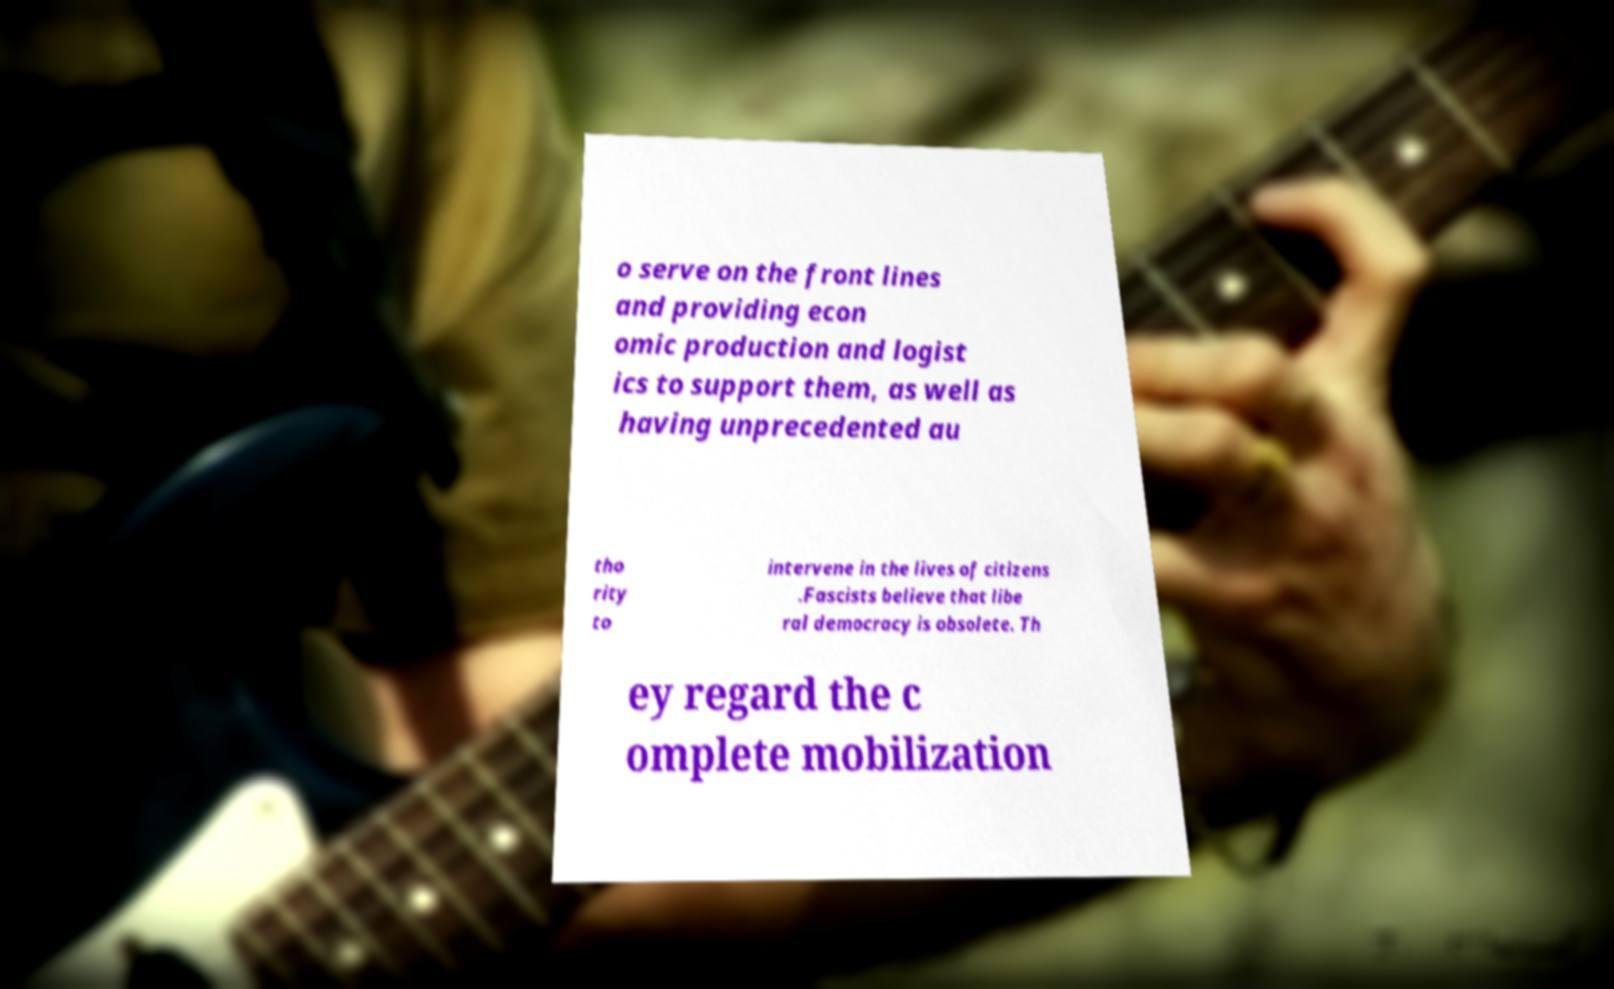What messages or text are displayed in this image? I need them in a readable, typed format. o serve on the front lines and providing econ omic production and logist ics to support them, as well as having unprecedented au tho rity to intervene in the lives of citizens .Fascists believe that libe ral democracy is obsolete. Th ey regard the c omplete mobilization 